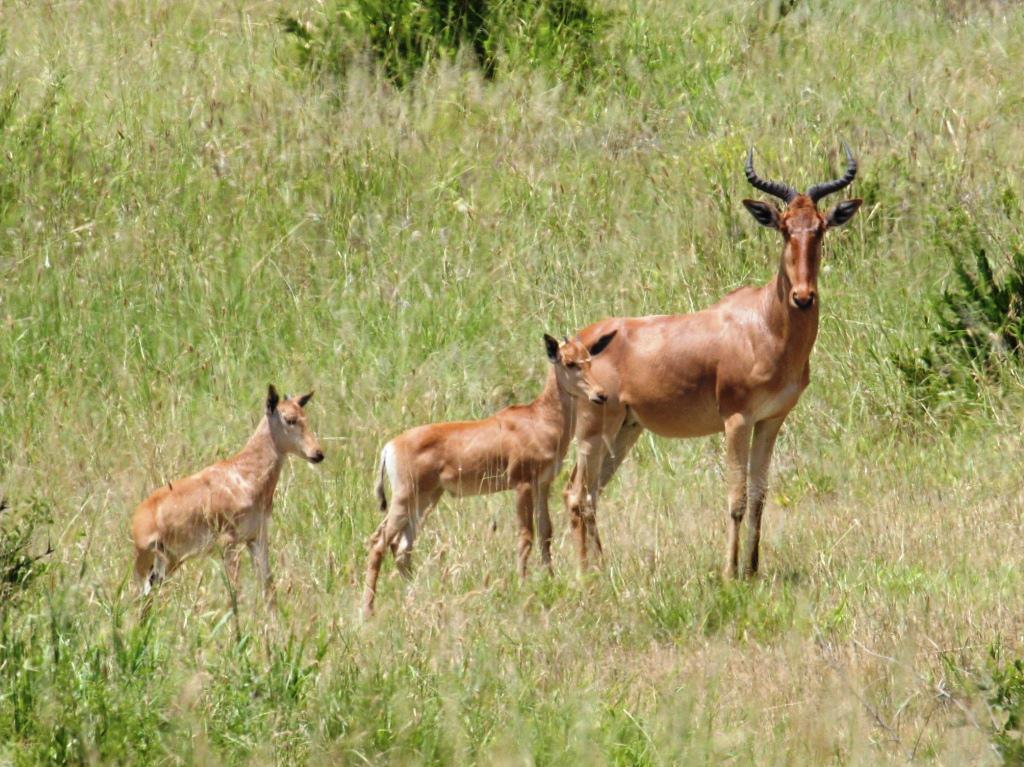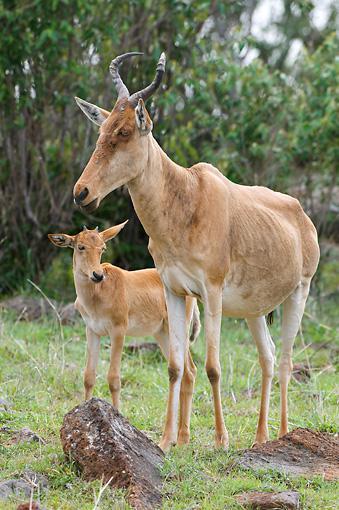The first image is the image on the left, the second image is the image on the right. Evaluate the accuracy of this statement regarding the images: "At least one image includes a young animal and an adult with horns.". Is it true? Answer yes or no. Yes. 